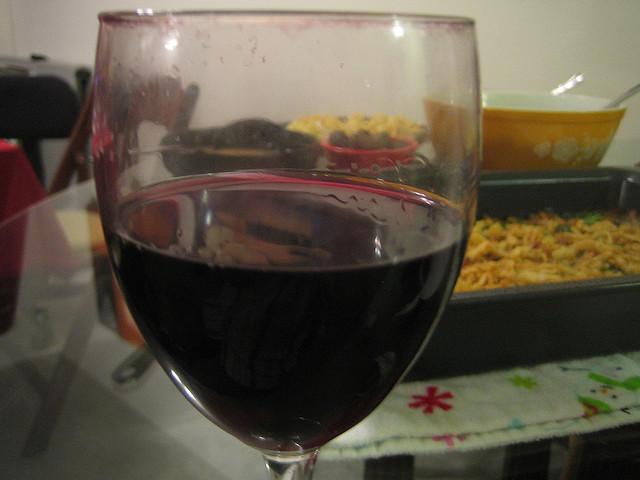How many glasses of wine are in the picture?
Write a very short answer. 1. Is this glass clean?
Short answer required. No. Would this drink be good with liver and fava beans?
Quick response, please. Yes. What is in the glass?
Answer briefly. Wine. Is a bottle in the picture?
Short answer required. No. 